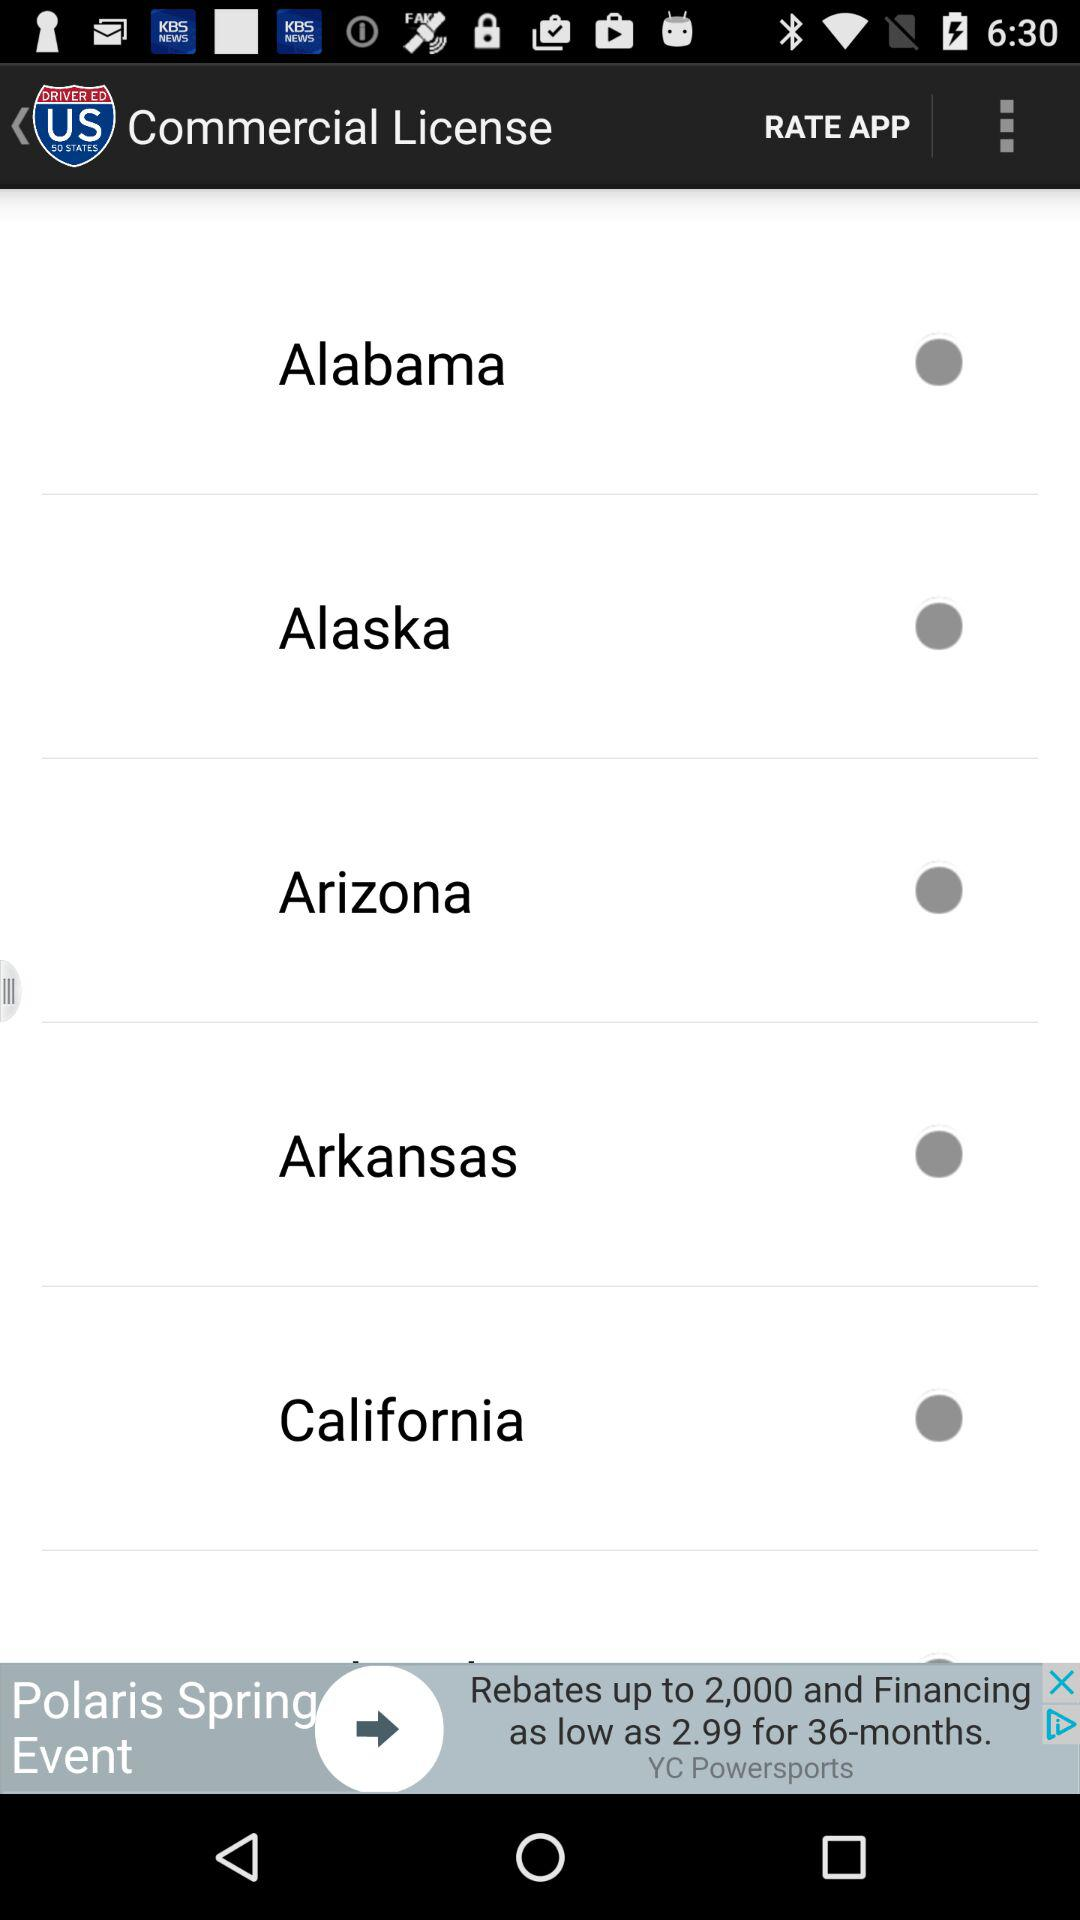What are the names of the mentioned states? The names are Alabama, Alaska, Arizona, Arkansas and California. 